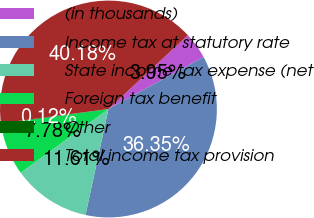Convert chart. <chart><loc_0><loc_0><loc_500><loc_500><pie_chart><fcel>(in thousands)<fcel>Income tax at statutory rate<fcel>State income tax expense (net<fcel>Foreign tax benefit<fcel>Other<fcel>Total income tax provision<nl><fcel>3.95%<fcel>36.35%<fcel>11.61%<fcel>7.78%<fcel>0.12%<fcel>40.18%<nl></chart> 